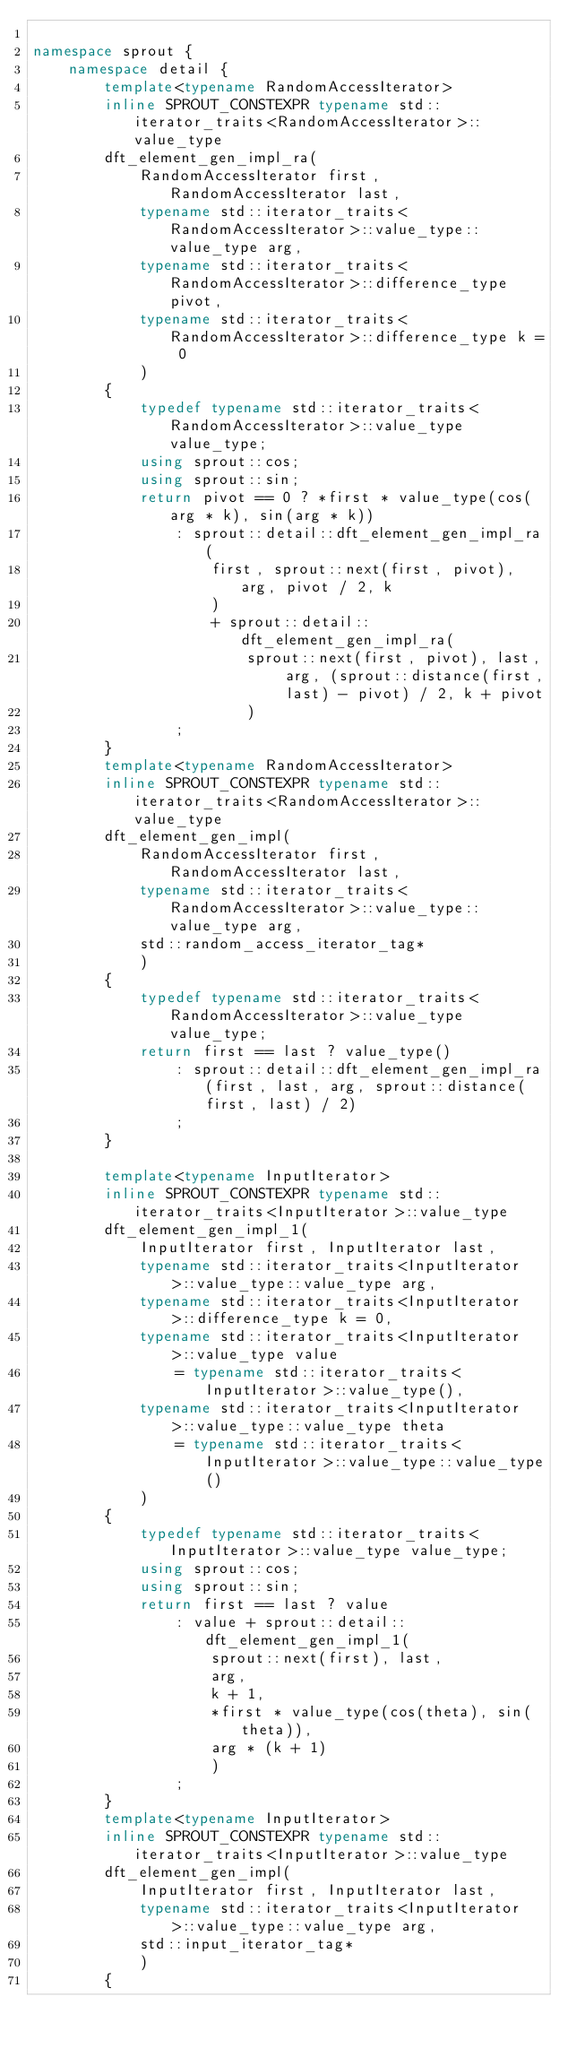<code> <loc_0><loc_0><loc_500><loc_500><_C++_>
namespace sprout {
	namespace detail {
		template<typename RandomAccessIterator>
		inline SPROUT_CONSTEXPR typename std::iterator_traits<RandomAccessIterator>::value_type
		dft_element_gen_impl_ra(
			RandomAccessIterator first, RandomAccessIterator last,
			typename std::iterator_traits<RandomAccessIterator>::value_type::value_type arg,
			typename std::iterator_traits<RandomAccessIterator>::difference_type pivot,
			typename std::iterator_traits<RandomAccessIterator>::difference_type k = 0
			)
		{
			typedef typename std::iterator_traits<RandomAccessIterator>::value_type value_type;
			using sprout::cos;
			using sprout::sin;
			return pivot == 0 ? *first * value_type(cos(arg * k), sin(arg * k))
				: sprout::detail::dft_element_gen_impl_ra(
					first, sprout::next(first, pivot), arg, pivot / 2, k
					)
					+ sprout::detail::dft_element_gen_impl_ra(
						sprout::next(first, pivot), last, arg, (sprout::distance(first, last) - pivot) / 2, k + pivot
						)
				;
		}
		template<typename RandomAccessIterator>
		inline SPROUT_CONSTEXPR typename std::iterator_traits<RandomAccessIterator>::value_type
		dft_element_gen_impl(
			RandomAccessIterator first, RandomAccessIterator last,
			typename std::iterator_traits<RandomAccessIterator>::value_type::value_type arg,
			std::random_access_iterator_tag*
			)
		{
			typedef typename std::iterator_traits<RandomAccessIterator>::value_type value_type;
			return first == last ? value_type()
				: sprout::detail::dft_element_gen_impl_ra(first, last, arg, sprout::distance(first, last) / 2)
				;
		}

		template<typename InputIterator>
		inline SPROUT_CONSTEXPR typename std::iterator_traits<InputIterator>::value_type
		dft_element_gen_impl_1(
			InputIterator first, InputIterator last,
			typename std::iterator_traits<InputIterator>::value_type::value_type arg,
			typename std::iterator_traits<InputIterator>::difference_type k = 0,
			typename std::iterator_traits<InputIterator>::value_type value
				= typename std::iterator_traits<InputIterator>::value_type(),
			typename std::iterator_traits<InputIterator>::value_type::value_type theta
				= typename std::iterator_traits<InputIterator>::value_type::value_type()
			)
		{
			typedef typename std::iterator_traits<InputIterator>::value_type value_type;
			using sprout::cos;
			using sprout::sin;
			return first == last ? value
				: value + sprout::detail::dft_element_gen_impl_1(
					sprout::next(first), last,
					arg,
					k + 1,
					*first * value_type(cos(theta), sin(theta)),
					arg * (k + 1)
					)
				;
		}
		template<typename InputIterator>
		inline SPROUT_CONSTEXPR typename std::iterator_traits<InputIterator>::value_type
		dft_element_gen_impl(
			InputIterator first, InputIterator last,
			typename std::iterator_traits<InputIterator>::value_type::value_type arg,
			std::input_iterator_tag*
			)
		{</code> 